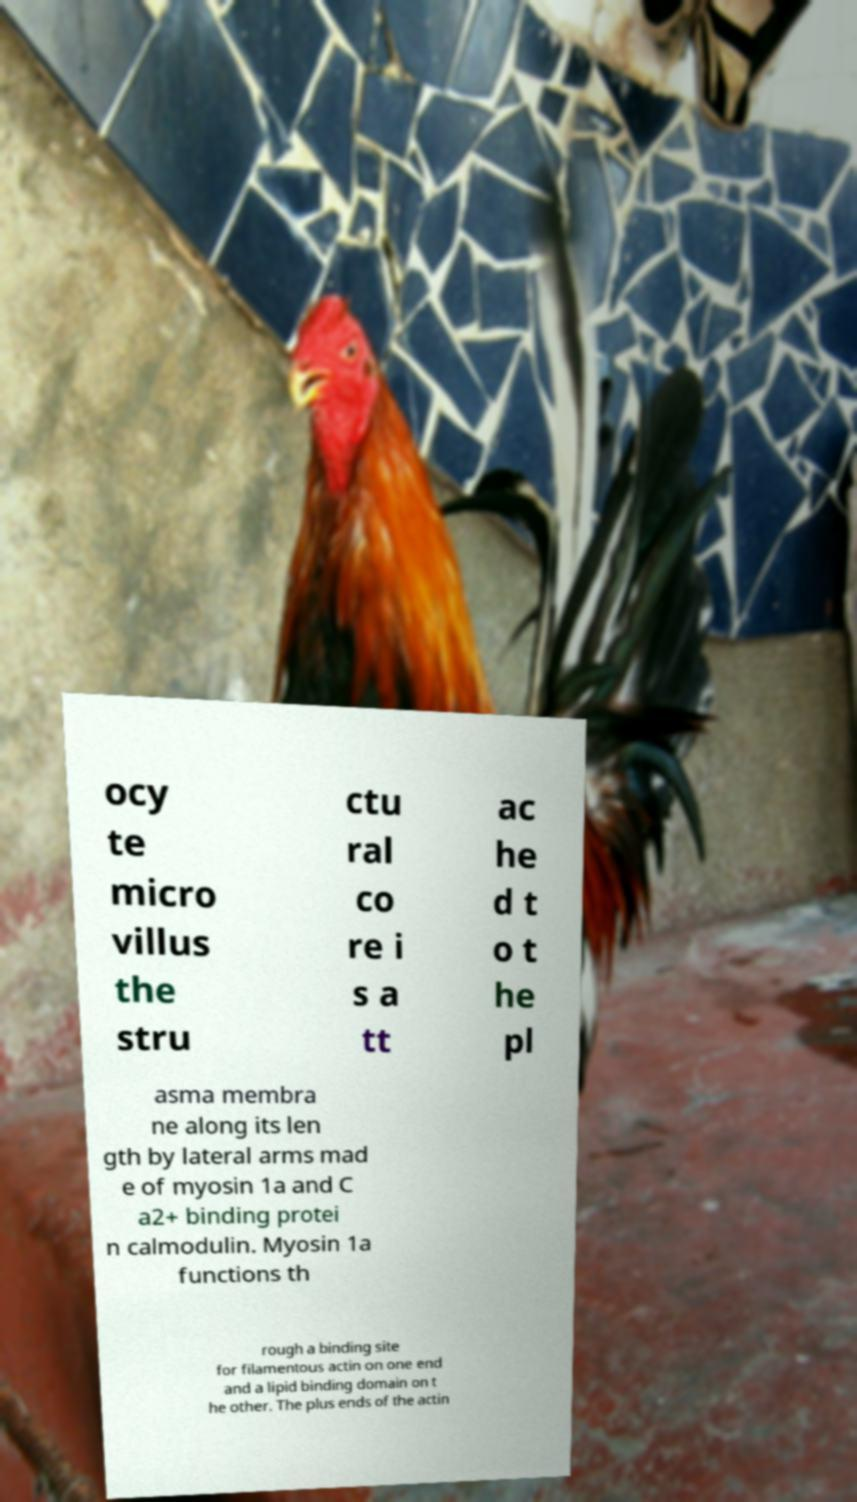Please read and relay the text visible in this image. What does it say? ocy te micro villus the stru ctu ral co re i s a tt ac he d t o t he pl asma membra ne along its len gth by lateral arms mad e of myosin 1a and C a2+ binding protei n calmodulin. Myosin 1a functions th rough a binding site for filamentous actin on one end and a lipid binding domain on t he other. The plus ends of the actin 